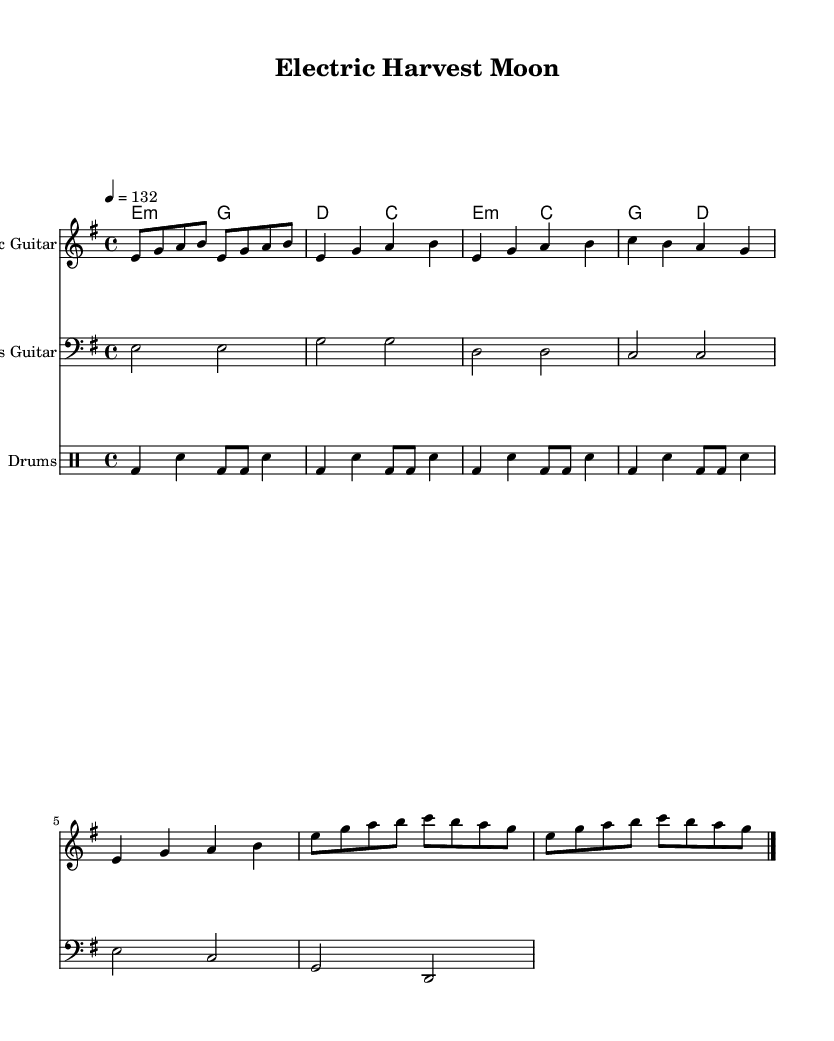What is the key signature of this music? The key signature indicates E minor, as shown by one sharp (F#) in the key signature section of the sheet music.
Answer: E minor What is the time signature of this music? The time signature is specified at the beginning of the piece and indicates 4/4, meaning there are four beats in each measure and the quarter note receives one beat.
Answer: 4/4 What is the tempo marking of this music? The tempo marking, found in the header section, is 132 beats per minute, indicating how fast the piece should be played.
Answer: 132 How many measures are in the verse section? By counting the measures specifically listed under the verse, we see that there are four measures in total.
Answer: 4 Which instrument plays the basic rock beat? The drums are specified to play the basic rock beat, as indicated in the drummode section of the score.
Answer: Drums What type of chords are used in the verse section? The verse section uses minor and major chords, particularly E minor and G major, as demonstrated in the chordmode part.
Answer: Minor and major How does the chorus differ from the verse in terms of chord structure? The chorus introduces C major in conjunction with E minor and maintains G major and D major from the verse, showcasing a different arrangement while still adhering to rock structure.
Answer: Different chord arrangement 